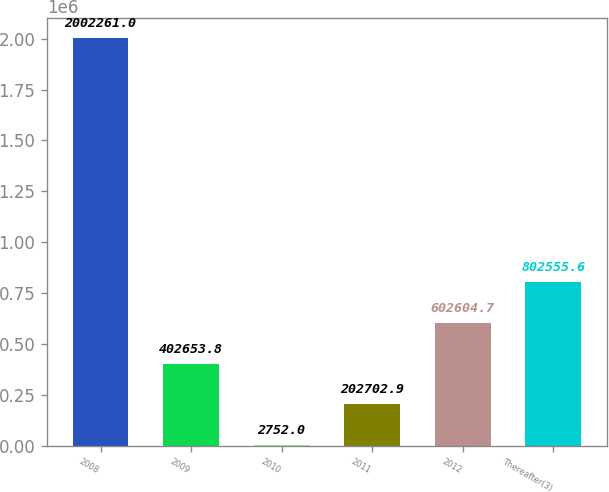Convert chart to OTSL. <chart><loc_0><loc_0><loc_500><loc_500><bar_chart><fcel>2008<fcel>2009<fcel>2010<fcel>2011<fcel>2012<fcel>Thereafter(3)<nl><fcel>2.00226e+06<fcel>402654<fcel>2752<fcel>202703<fcel>602605<fcel>802556<nl></chart> 